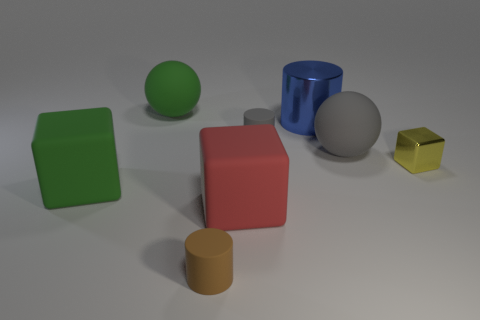Does the small metallic block have the same color as the big metal cylinder?
Make the answer very short. No. Is the number of small matte objects that are behind the big gray rubber ball less than the number of balls?
Give a very brief answer. Yes. There is a rubber ball right of the small brown object; what color is it?
Your answer should be compact. Gray. The big gray thing is what shape?
Your answer should be very brief. Sphere. Is there a large blue thing in front of the tiny cylinder behind the cube that is behind the large green cube?
Your response must be concise. No. What is the color of the block that is to the right of the cylinder right of the tiny rubber cylinder that is behind the tiny brown matte cylinder?
Provide a succinct answer. Yellow. What is the material of the green object that is the same shape as the small yellow object?
Provide a short and direct response. Rubber. What is the size of the rubber cylinder behind the sphere in front of the blue object?
Your answer should be compact. Small. There is a block that is in front of the big green matte block; what is it made of?
Your answer should be very brief. Rubber. What size is the red block that is the same material as the tiny brown cylinder?
Offer a very short reply. Large. 